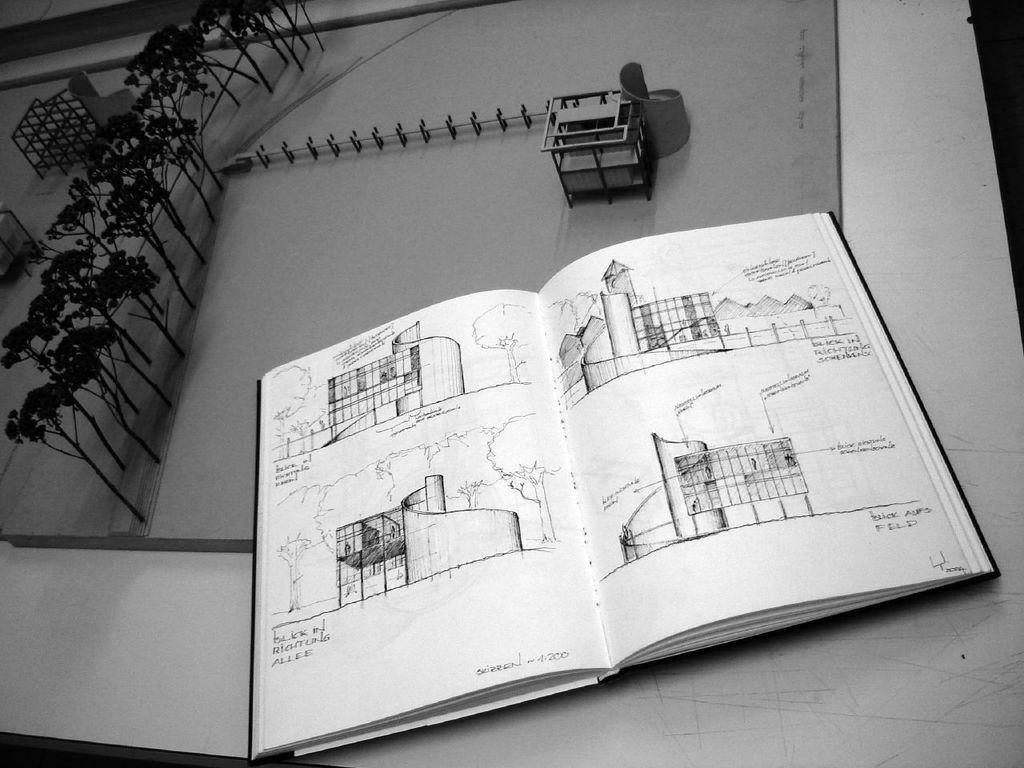What is depicted on the piece of paper in the image? There is a piece of paper with drawings on it. What else can be seen in the image besides the piece of paper? There is an open book in the image. Are there any drawings in the open book? Yes, the open book also contains drawings. What type of texture can be felt on the drawings in the image? The image does not provide information about the texture of the drawings, so it cannot be determined from the image. 